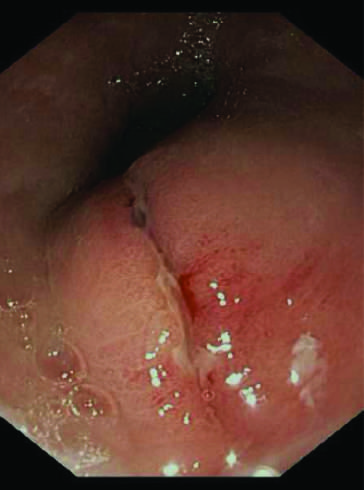does the palisade of cartilage tear?
Answer the question using a single word or phrase. No 